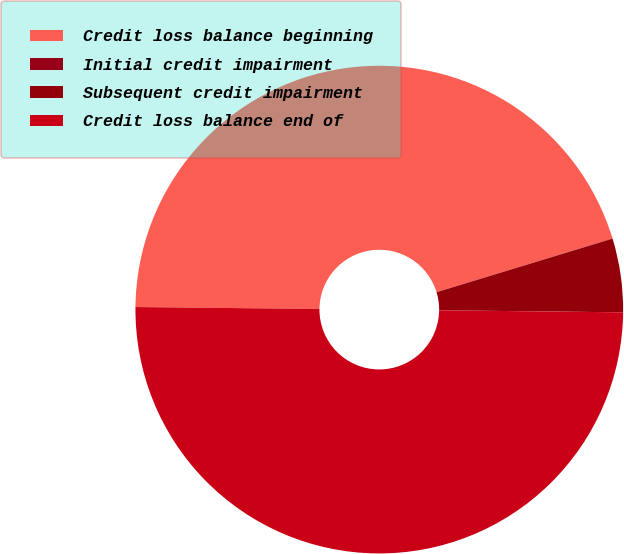Convert chart. <chart><loc_0><loc_0><loc_500><loc_500><pie_chart><fcel>Credit loss balance beginning<fcel>Initial credit impairment<fcel>Subsequent credit impairment<fcel>Credit loss balance end of<nl><fcel>45.12%<fcel>0.01%<fcel>4.88%<fcel>49.99%<nl></chart> 